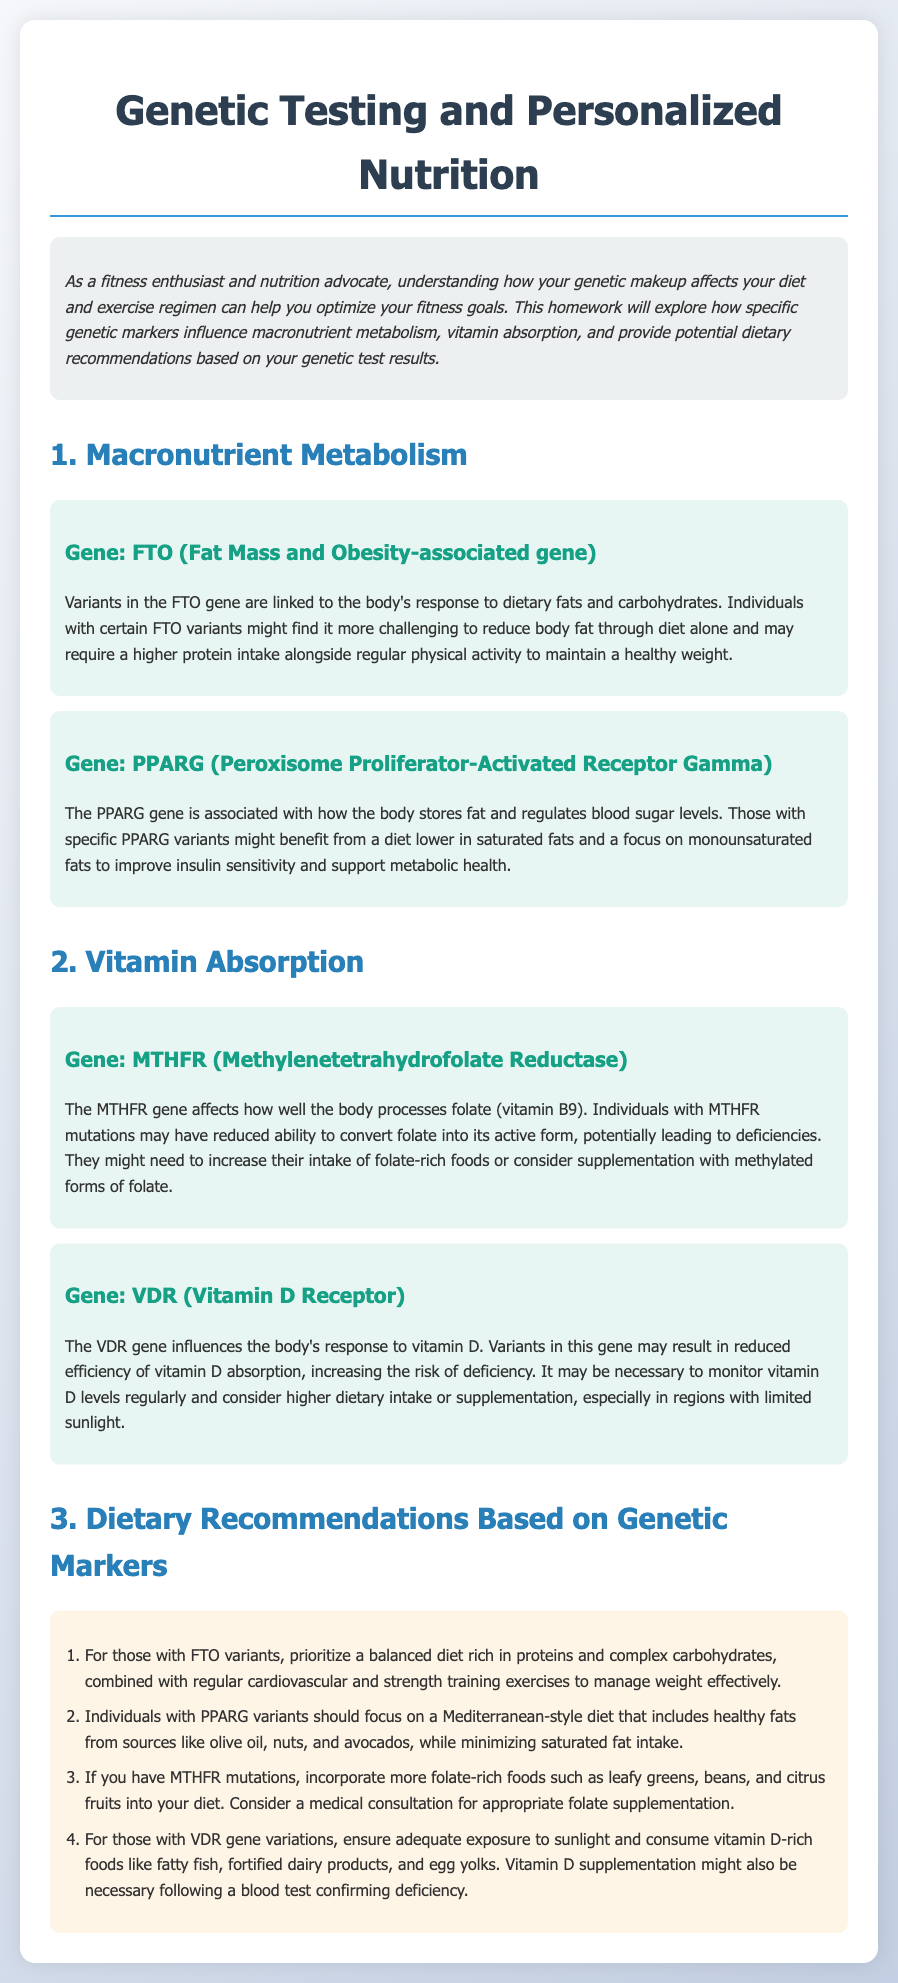What is the title of the homework document? The title is found in the header of the document, indicating the main focus of the content.
Answer: Genetic Testing and Personalized Nutrition Homework What gene is associated with fat mass and obesity? The gene's association with fat mass is clearly indicated in its dedicated section.
Answer: FTO Which gene influences folate metabolism? The document explicitly mentions a gene that affects how folate is processed in the body.
Answer: MTHFR What dietary focus is recommended for individuals with PPARG variants? The recommendation section provides dietary guidance specifically related to the gene PPARG.
Answer: Mediterranean-style diet What should individuals with VDR gene variations ensure regarding vitamin D? This is mentioned in the context of dietary and lifestyle recommendations associated with the VDR gene.
Answer: Adequate exposure to sunlight What type of exercise is suggested for those with FTO variants? The exercise regimen is specified as part of the recommendations for managing weight in individuals with specific genetic markers.
Answer: Regular cardiovascular and strength training How many dietary recommendations are provided in the document? The number of recommendations can be counted in the list provided under dietary recommendations.
Answer: Four What is recommended for those with MTHFR mutations regarding food? This recommendation focuses on what type of food to incorporate into the diet based on genetic testing results.
Answer: Folate-rich foods What might be necessary for individuals with reduced vitamin D absorption? The document suggests a specific action concerning vitamin D for those who may have difficulty absorbing it.
Answer: Vitamin D supplementation 